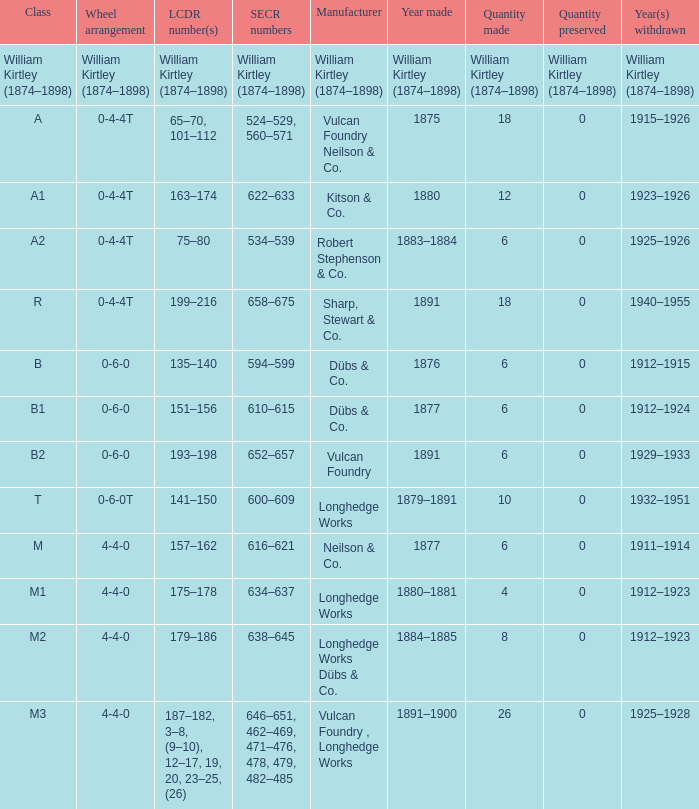Which SECR numbers have a class of b1? 610–615. 